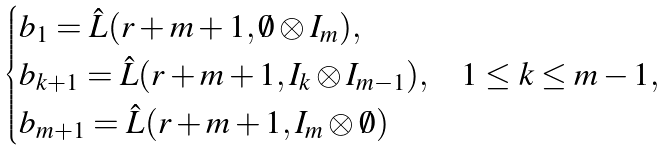Convert formula to latex. <formula><loc_0><loc_0><loc_500><loc_500>\begin{cases} b _ { 1 } = \hat { L } ( r + m + 1 , \emptyset \otimes I _ { m } ) , \\ b _ { k + 1 } = \hat { L } ( r + m + 1 , I _ { k } \otimes I _ { m - 1 } ) , & 1 \leq k \leq m - 1 , \\ b _ { m + 1 } = \hat { L } ( r + m + 1 , I _ { m } \otimes \emptyset ) \end{cases}</formula> 